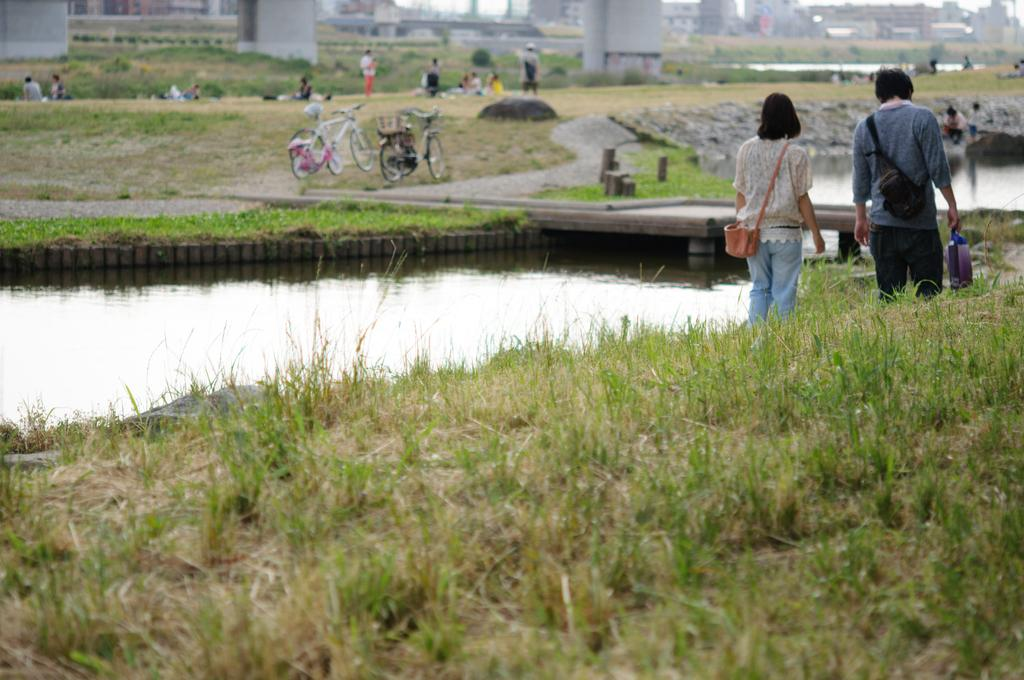What type of terrain is at the bottom of the image? There is grass and a small pond at the bottom of the image. Are there any people present in the image? Yes, there are people visible in the image. What type of vehicles can be seen in the image? There are cycles in the image. What can be seen in the background of the image? There are buildings, grass, and pillars in the background of the image. Where is the hose placed in the image? There is no hose present in the image. How many drops of water can be seen falling from the sky in the image? There is no rain or water drops visible in the image. 